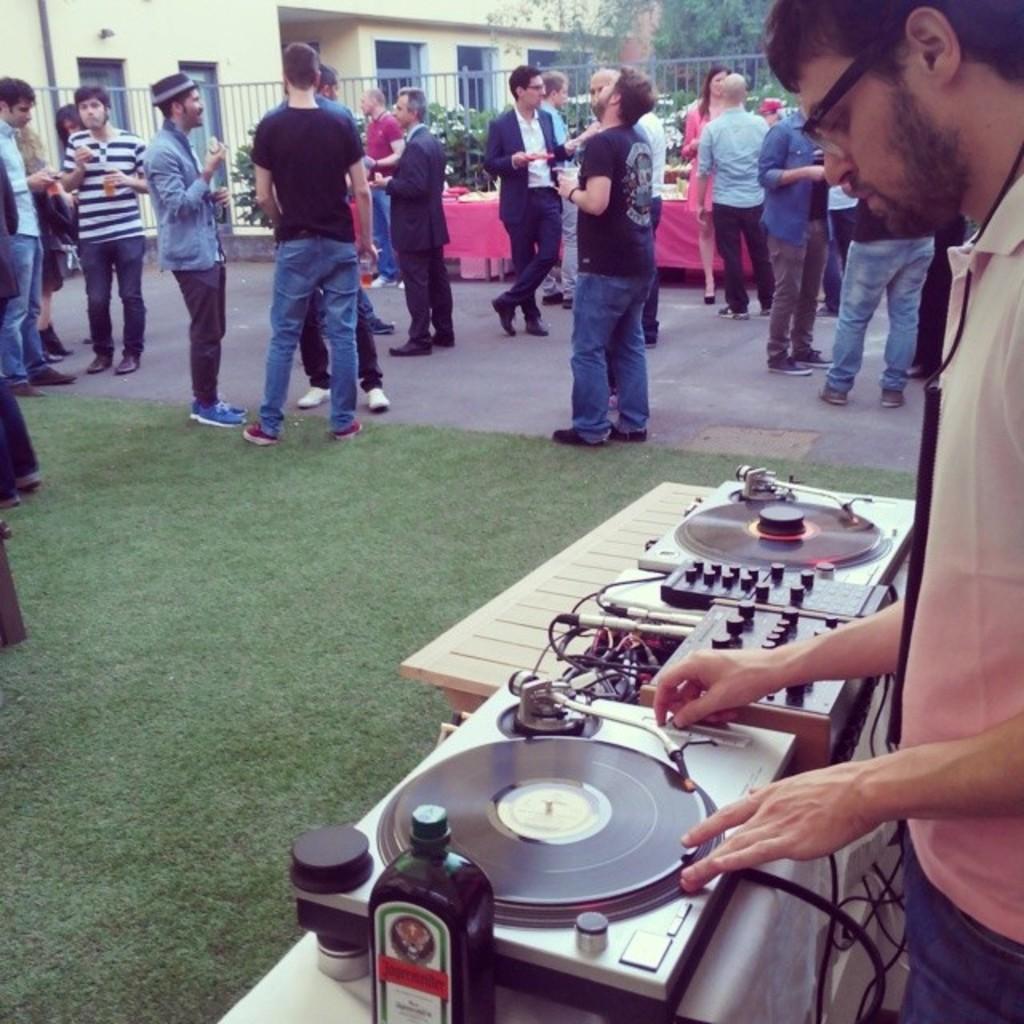How would you summarize this image in a sentence or two? In this image I can see a person is standing in front of a table and on the table I can see a music system and a bottle. In the background I can see some grass, few persons standing, few trees, the railing and few buildings. I can see few windows of the buildings. 